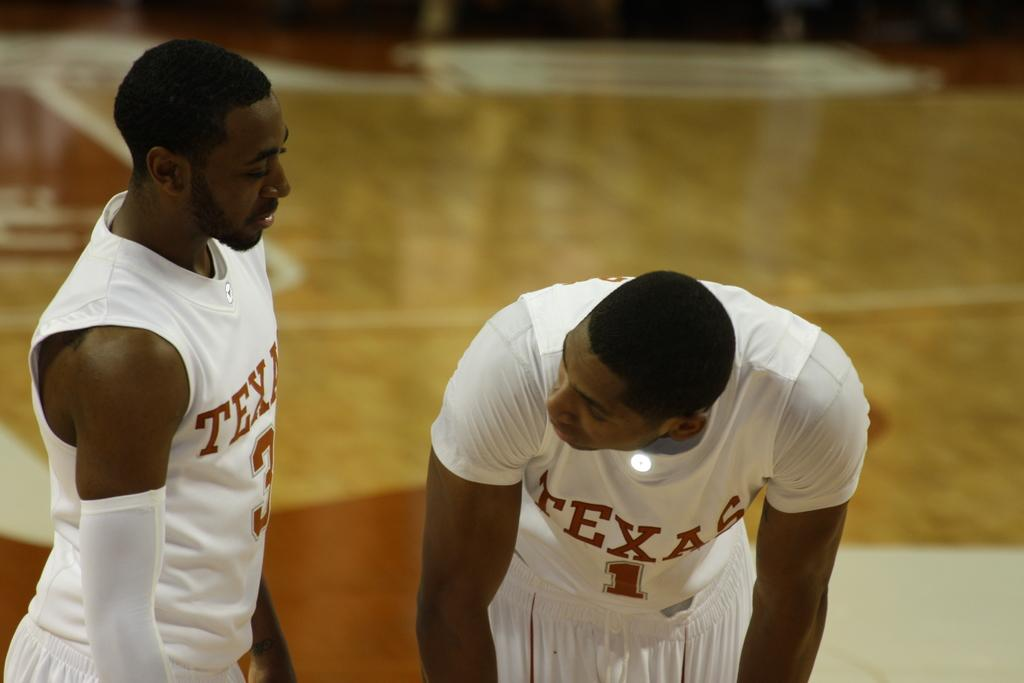<image>
Relay a brief, clear account of the picture shown. Number 1 from Texas is shown on the player's jersey. 